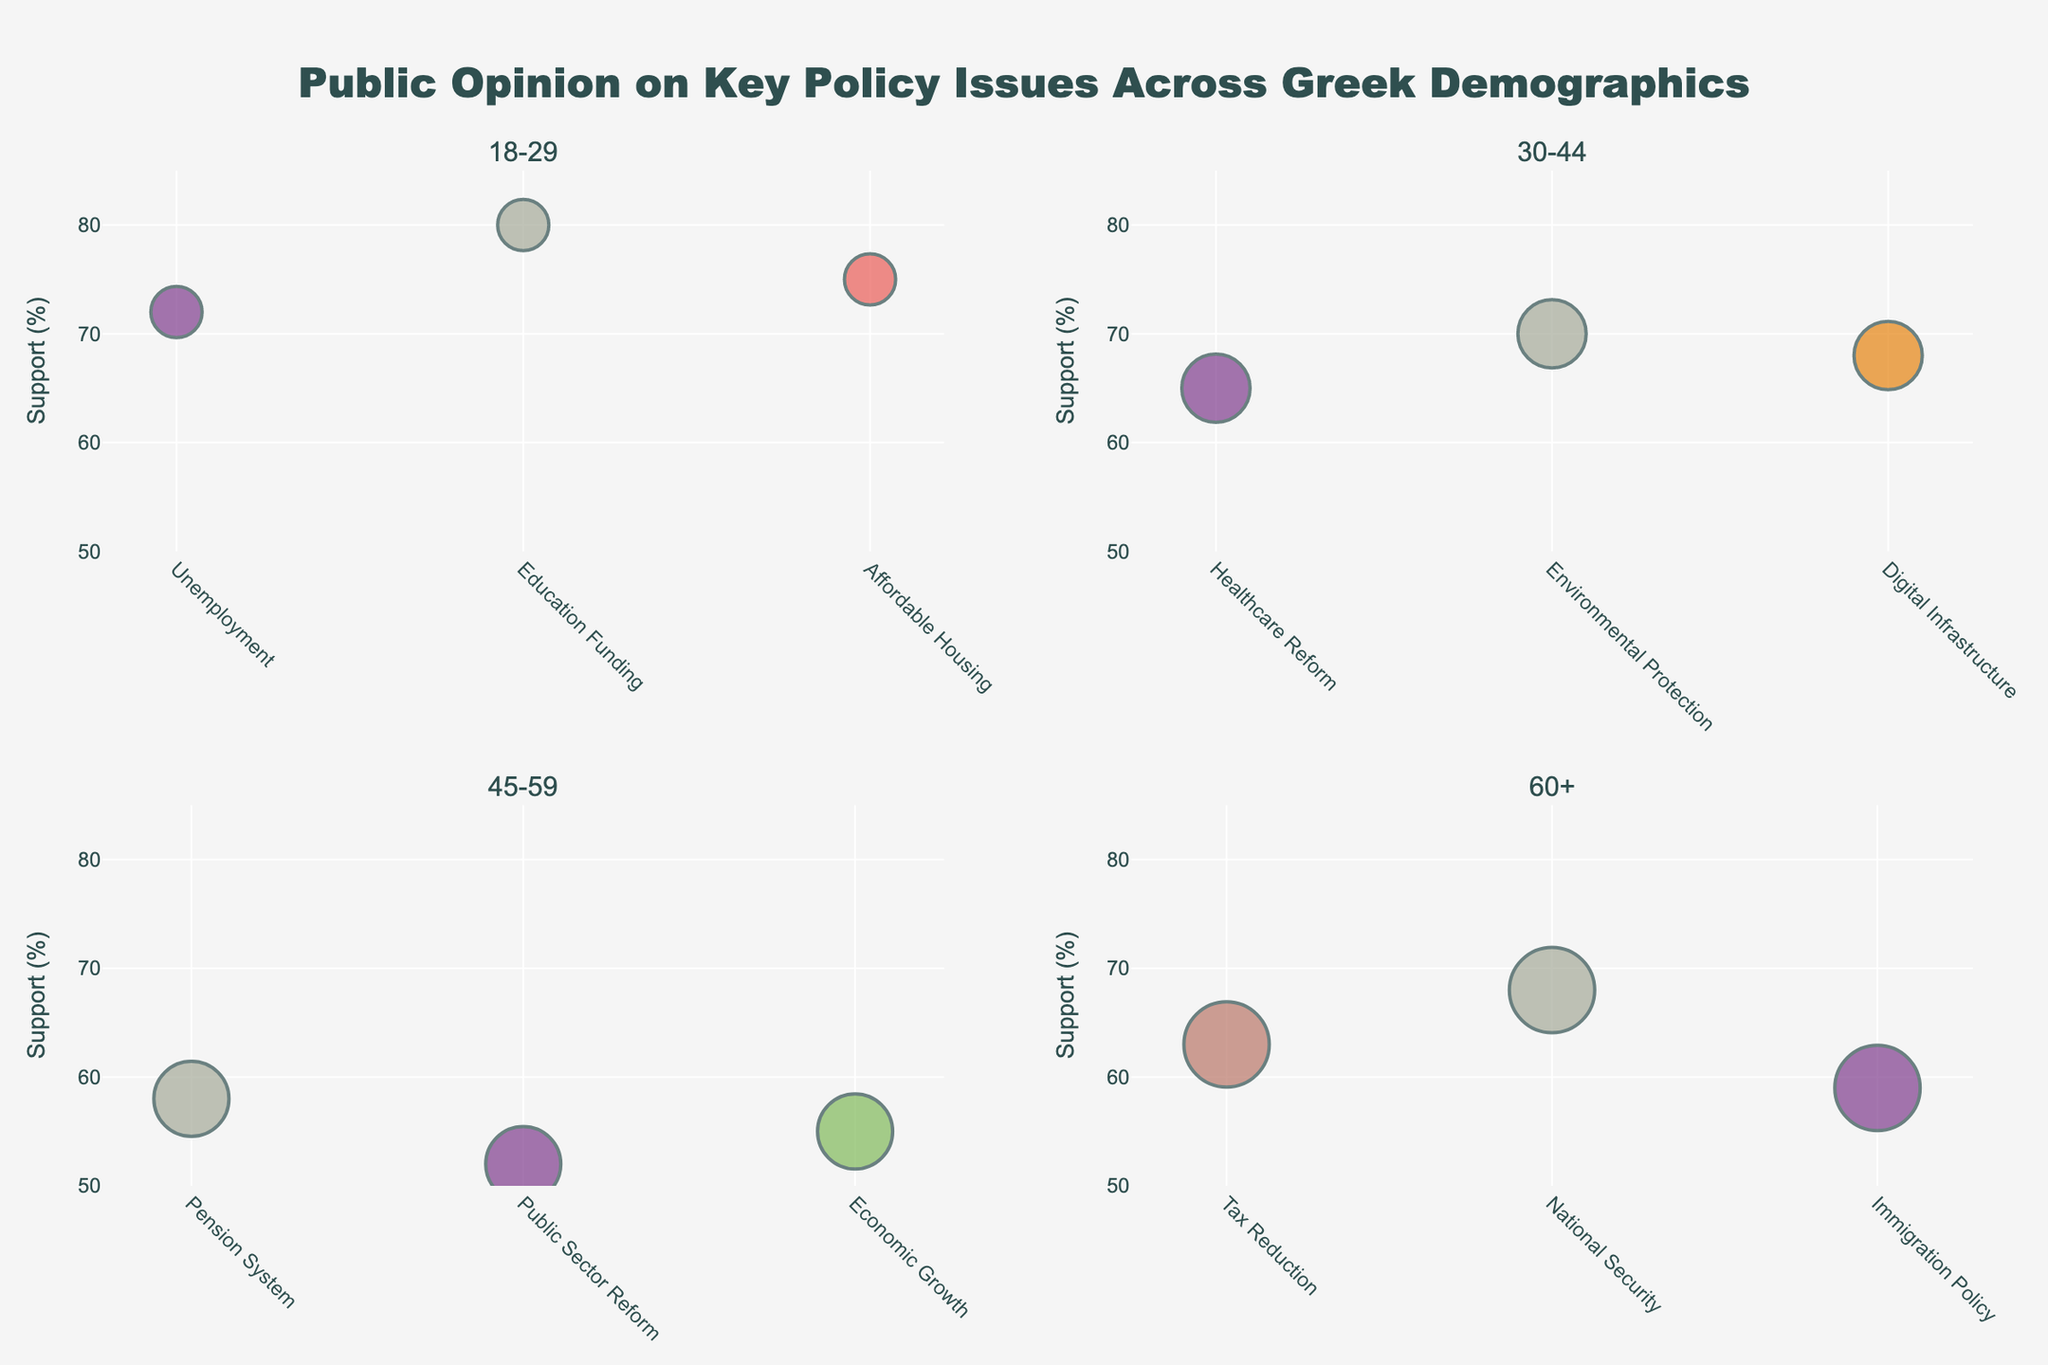What is the title of the figure? The title of the figure is displayed prominently at the top of the plot. It reads "Public Opinion on Key Policy Issues Across Greek Demographics".
Answer: Public Opinion on Key Policy Issues Across Greek Demographics Which policy issue has the highest support percentage among the 18-29 age group? By looking at the bubble corresponding to the 18-29 age group, the policy issue with the highest support percentage is "Education Funding" at 80%.
Answer: Education Funding What is the smallest bubble in the 45-59 age group subplot? The smallest bubble represents the policy issue with the smallest population size. In the 45-59 age group, this is "Public Sector Reform".
Answer: Public Sector Reform What is the average support percentage for the policy issues in the 60+ age group? The support percentages for the 60+ age group are: Tax Reduction (63%), National Security (68%), and Immigration Policy (59%). The average is calculated as (63+68+59)/3 = 63.33%.
Answer: 63.33% Compare the support percentage for Unemployment and Tax Reduction. Which has higher support and by how much? Unemployment has a support percentage of 72% and Tax Reduction has 63%. The difference is 72 - 63 = 9%.
Answer: Unemployment by 9% Which age group has the largest population size represented in any of their bubbles? The largest population size is 2500000 in the 60+ age group.
Answer: 60+ How does the number of data points differ between age groups 18-29 and 30-44? The subplot for the 18-29 age group shows three data points, while the subplot for the 30-44 age group also shows three data points. Therefore, the number of data points is the same for both age groups.
Answer: No difference What policy issue is most supported by the 30-44 age group? The most supported policy issue in the 30-44 age group is "Environmental Protection" with a support percentage of 70%.
Answer: Environmental Protection Which two age groups have the closest average support percentages across their issues? Calculate the average support percentages: 
18-29: (72+80+75)/3 = 75.67%
30-44: (65+70+68)/3 = 67.67%
45-59: (58+52+55)/3 = 55%
60+: (63+68+59)/3 = 63.33%
The closest averages are between 60+ (63.33%) and 45-59 (55%) with a difference of 8.33%.
Answer: 60+ and 45-59 Which policy issue is least supported by the 45-59 age group? The least supported policy issue in the 45-59 age group is "Public Sector Reform" with 52%.
Answer: Public Sector Reform 